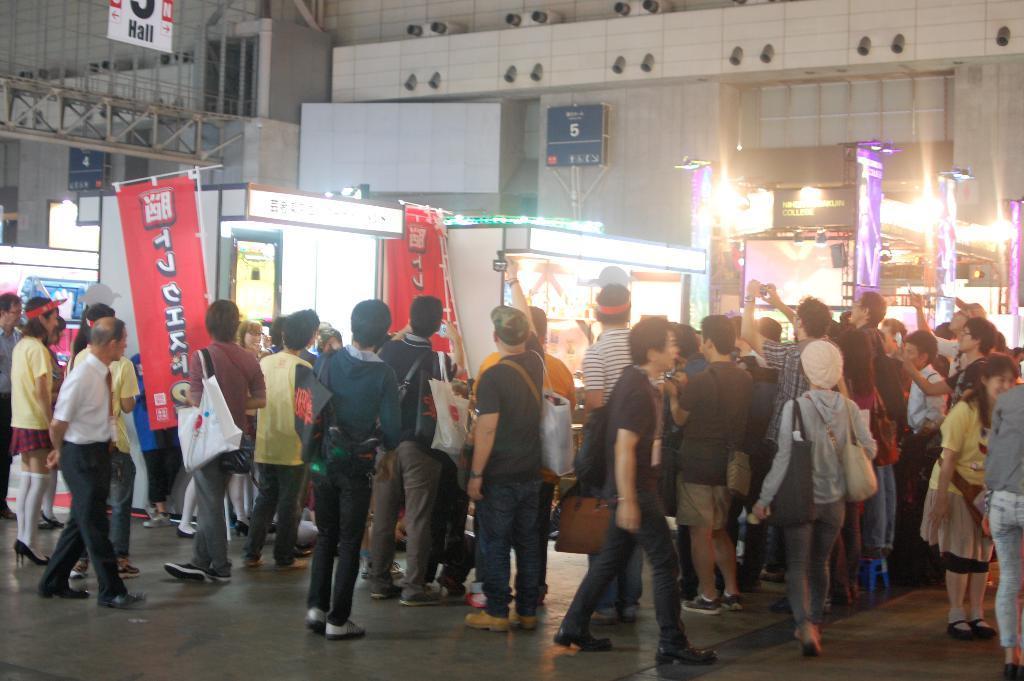Could you give a brief overview of what you see in this image? In the foreground I can see a crowd on the road. In the background I can see tents, buildings, boards, lights and metal rods. This image is taken may be during night on the road. 